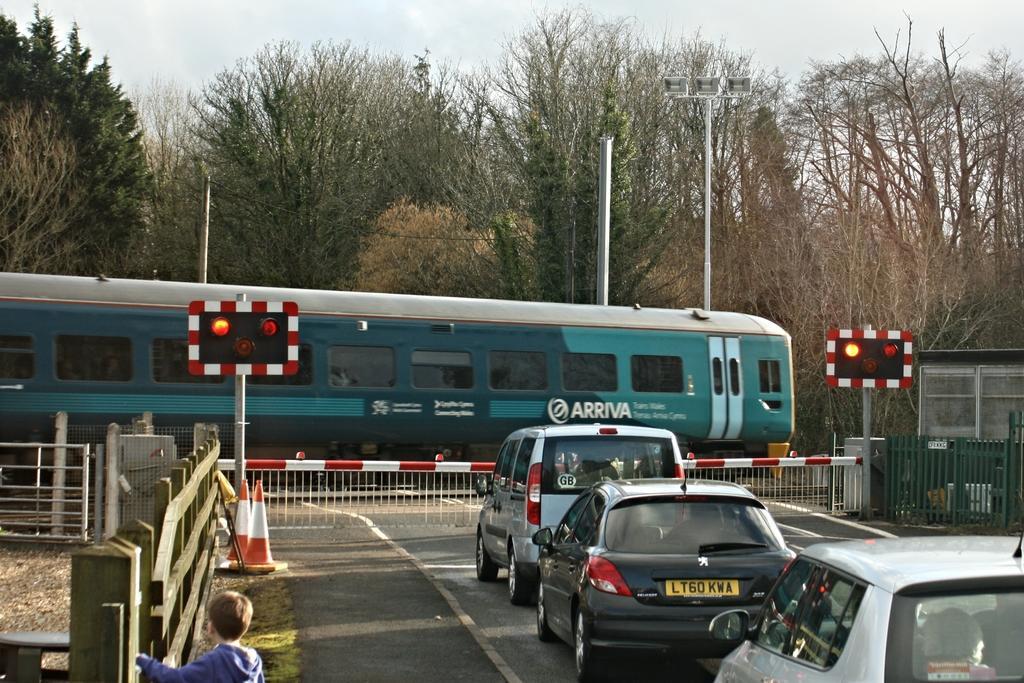Describe this image in one or two sentences. In this picture there is a train on the railway track. Here we can see three cars which is on the road. Here we can see gate and traffic signal. On the bottom left there is a boy who is wearing hoodie and standing near to the wooden fencing. Here we can see traffic cones. On the right there hut which is near to the steel fencing. On the background we can see trees, street light and pole. On the top we can see sky and clouds. 